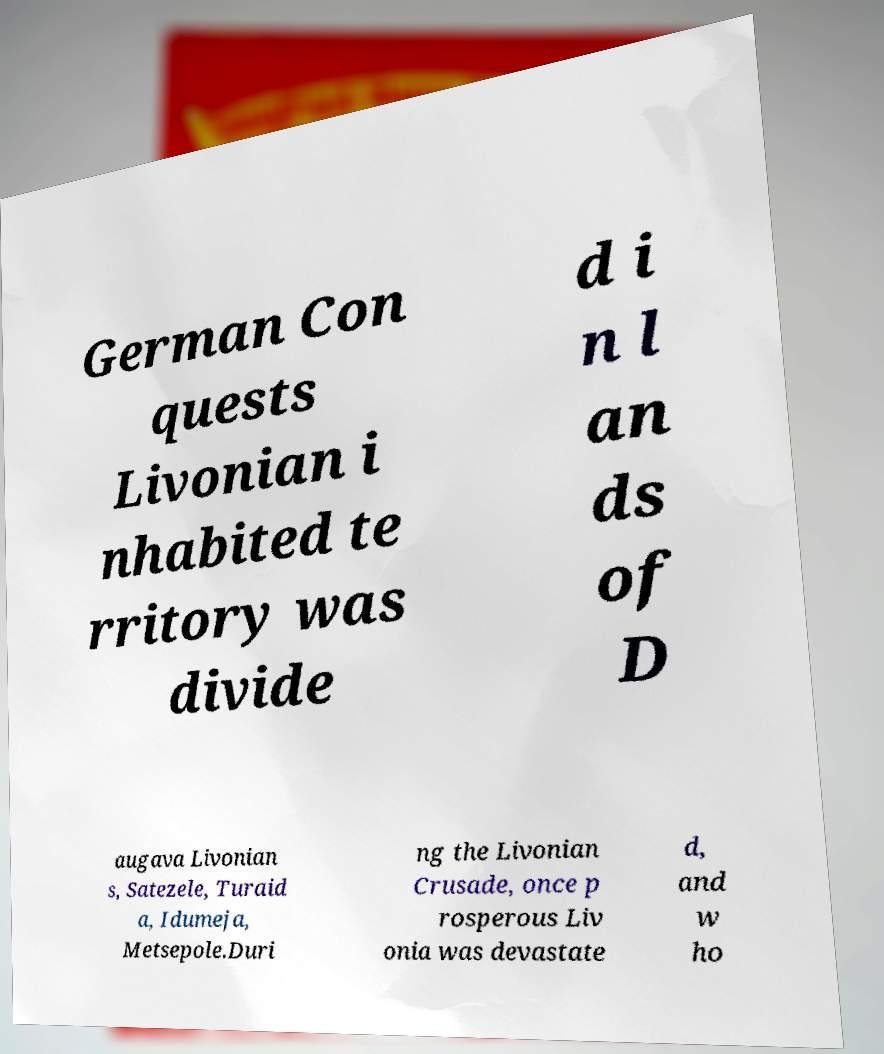There's text embedded in this image that I need extracted. Can you transcribe it verbatim? German Con quests Livonian i nhabited te rritory was divide d i n l an ds of D augava Livonian s, Satezele, Turaid a, Idumeja, Metsepole.Duri ng the Livonian Crusade, once p rosperous Liv onia was devastate d, and w ho 